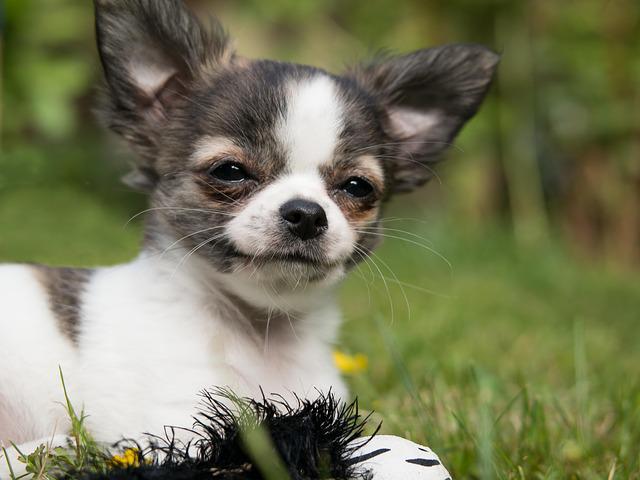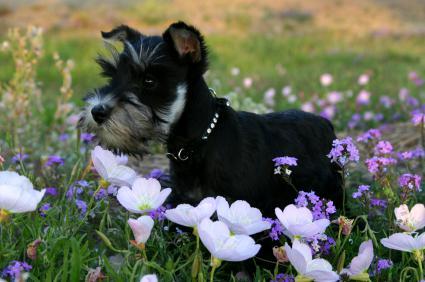The first image is the image on the left, the second image is the image on the right. Analyze the images presented: Is the assertion "The dog in the image on the left is indoors" valid? Answer yes or no. No. The first image is the image on the left, the second image is the image on the right. Evaluate the accuracy of this statement regarding the images: "There is a dog walking on the pavement in the right image.". Is it true? Answer yes or no. No. 